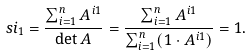Convert formula to latex. <formula><loc_0><loc_0><loc_500><loc_500>\ s i _ { 1 } = \frac { \sum _ { i = 1 } ^ { n } A ^ { i 1 } } { \det A } = \frac { \sum _ { i = 1 } ^ { n } A ^ { i 1 } } { \sum _ { i = 1 } ^ { n } ( 1 \cdot A ^ { i 1 } ) } = 1 .</formula> 